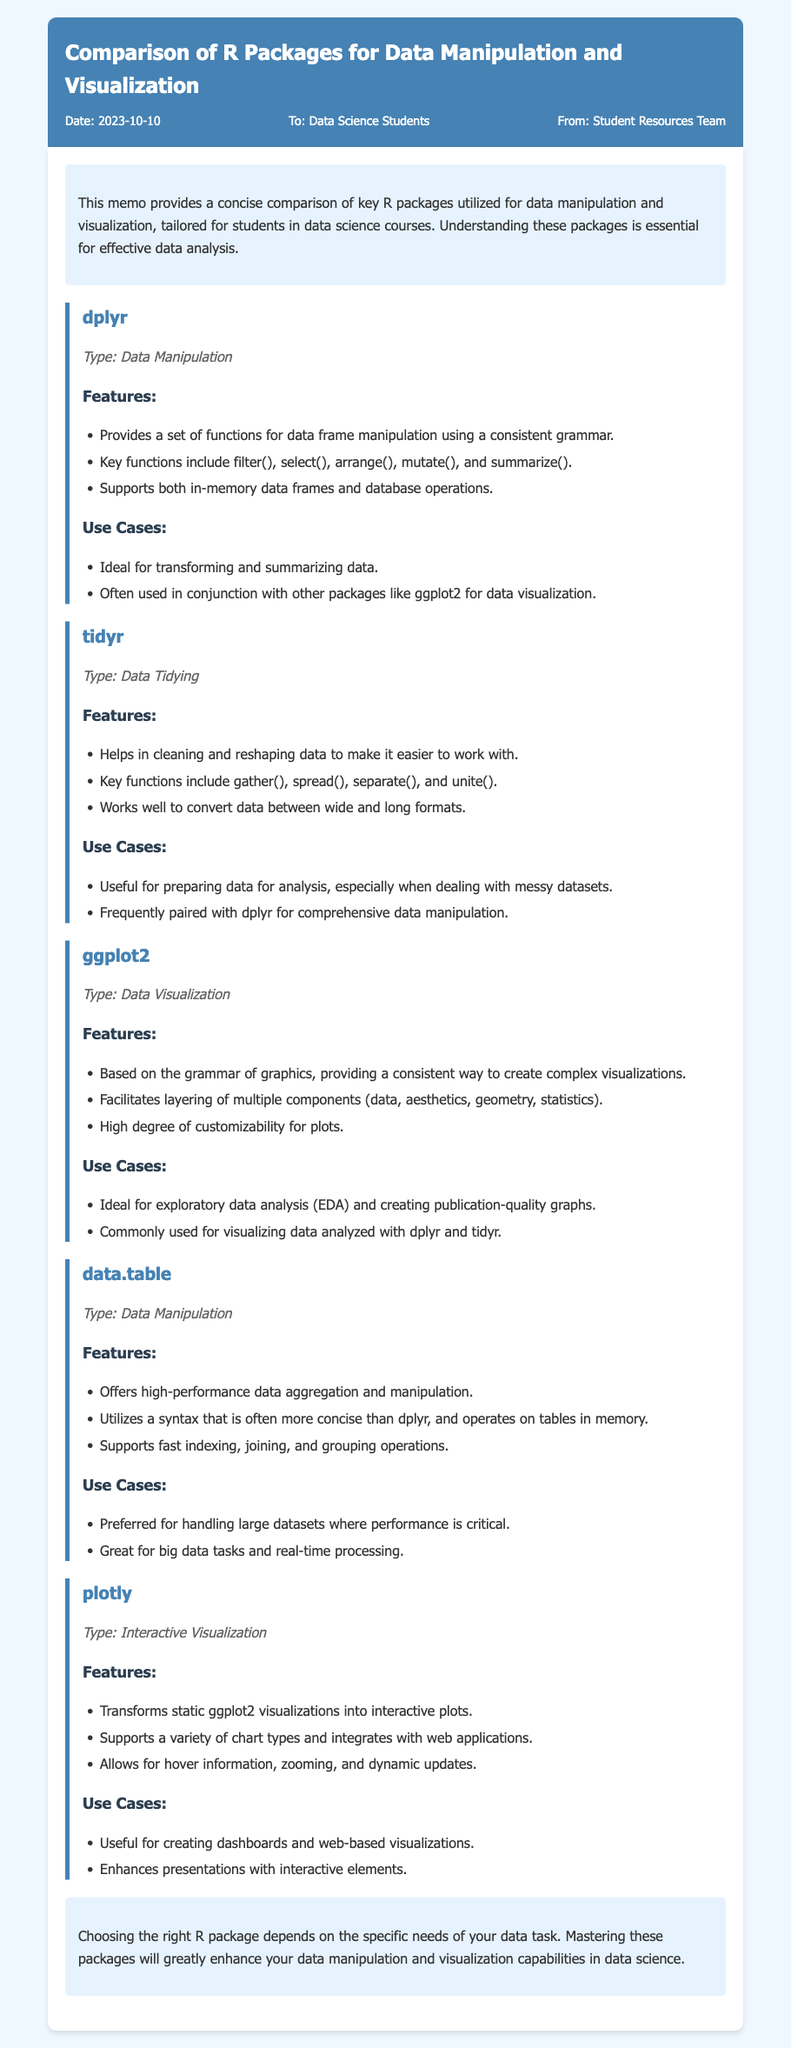What is the date of the memo? The date of the memo is mentioned in the header section, indicating when it was created.
Answer: 2023-10-10 Who is the intended audience for the memo? The memo specifies that it is directed to a particular group of students, which provides insight into its purpose.
Answer: Data Science Students Which package is primarily used for data visualization? The memo clearly categorizes each package by its purpose, pointing to one specifically designed for visual representation.
Answer: ggplot2 What key function does dplyr include for data manipulation? The memo lists important functions associated with dplyr, which highlight its capabilities in handling data.
Answer: filter() Which package is preferred for handling large datasets? The memo explicitly mentions a package that excels in performance and efficiency when dealing with substantial amounts of data.
Answer: data.table What type of visualization does plotly provide? The document defines the capabilities of plotly, emphasizing a specific kind of visualization it specializes in.
Answer: Interactive Visualization What type of package is tidyr? The memo classifies tidyr among different types of data processing tools, indicating its focus area.
Answer: Data Tidying What is a key feature of ggplot2? The memo describes a fundamental aspect of ggplot2 that enhances its functionality in creating visualizations.
Answer: Grammar of graphics What does the conclusion of the memo advise? The conclusion offers a summary recommendation on how to approach the use of the discussed packages.
Answer: Mastering these packages 